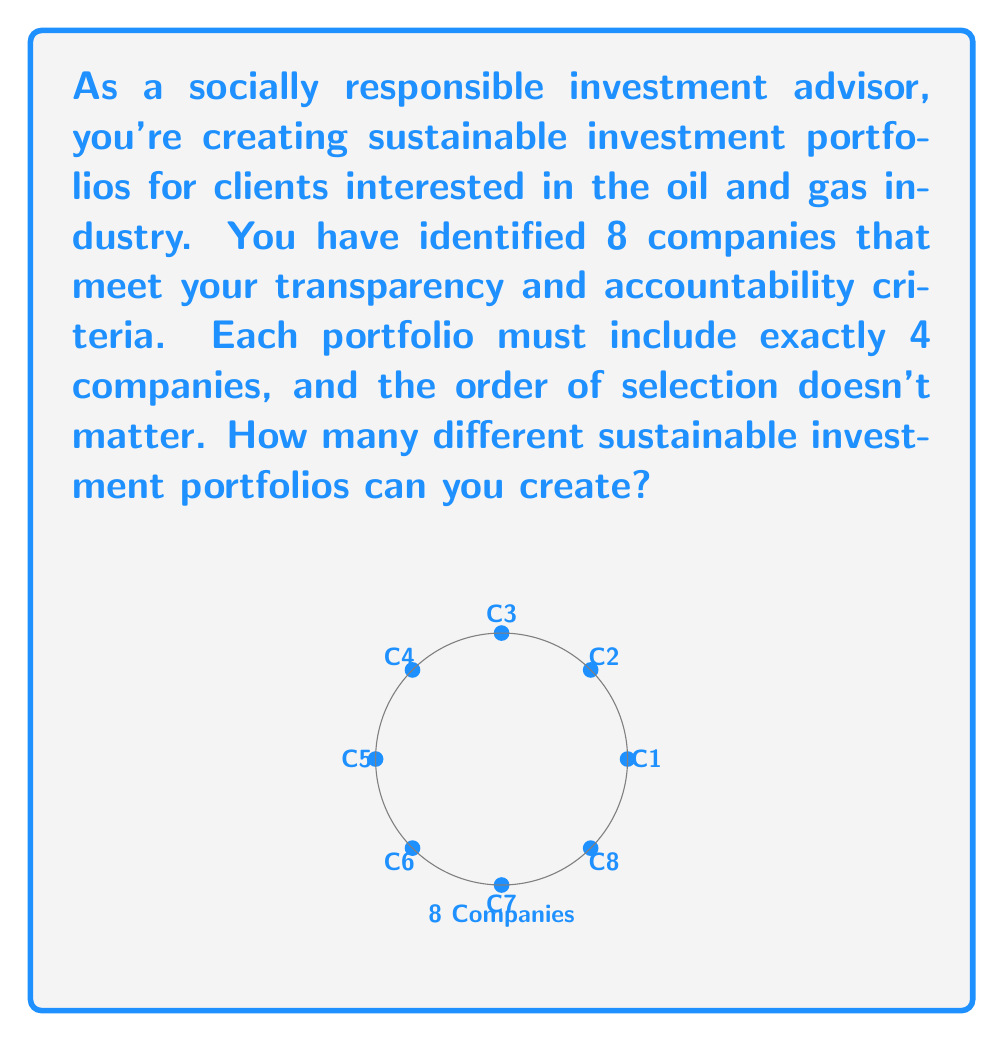Give your solution to this math problem. To solve this problem, we need to use the combination formula from combinatorics. Here's the step-by-step solution:

1) We are selecting 4 companies out of 8, where the order doesn't matter. This is a combination problem.

2) The formula for combinations is:

   $$C(n,r) = \frac{n!}{r!(n-r)!}$$

   Where $n$ is the total number of items to choose from, and $r$ is the number of items being chosen.

3) In this case, $n = 8$ (total companies) and $r = 4$ (companies in each portfolio).

4) Let's substitute these values into the formula:

   $$C(8,4) = \frac{8!}{4!(8-4)!} = \frac{8!}{4!4!}$$

5) Expand this:
   
   $$\frac{8 \times 7 \times 6 \times 5 \times 4!}{4! \times 4 \times 3 \times 2 \times 1}$$

6) The $4!$ cancels out in the numerator and denominator:

   $$\frac{8 \times 7 \times 6 \times 5}{4 \times 3 \times 2 \times 1}$$

7) Multiply the numerator and denominator:

   $$\frac{1680}{24} = 70$$

Therefore, you can create 70 different sustainable investment portfolios.
Answer: 70 portfolios 